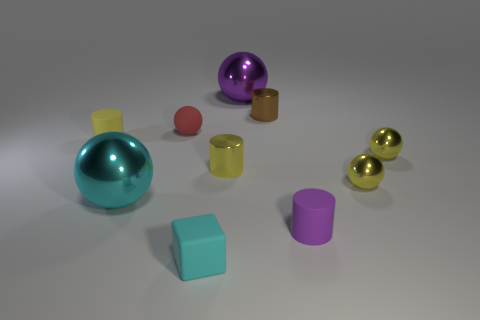What is the material of the ball that is the same color as the tiny cube?
Your response must be concise. Metal. What number of objects are cyan metal objects or metal balls that are on the right side of the brown shiny thing?
Your response must be concise. 3. What number of tiny blue balls are there?
Keep it short and to the point. 0. Is there a red rubber thing that has the same size as the brown object?
Your answer should be compact. Yes. Are there fewer brown cylinders that are to the left of the tiny red rubber ball than small rubber cubes?
Your answer should be very brief. Yes. Is the rubber sphere the same size as the cyan ball?
Your answer should be very brief. No. There is a cyan sphere that is made of the same material as the brown cylinder; what size is it?
Offer a very short reply. Large. How many rubber objects are the same color as the small rubber block?
Your answer should be compact. 0. Is the number of tiny yellow metallic spheres that are to the left of the tiny matte block less than the number of tiny matte balls left of the small yellow rubber cylinder?
Provide a succinct answer. No. Is the shape of the small brown object that is to the right of the tiny cyan cube the same as  the large cyan thing?
Provide a succinct answer. No. 